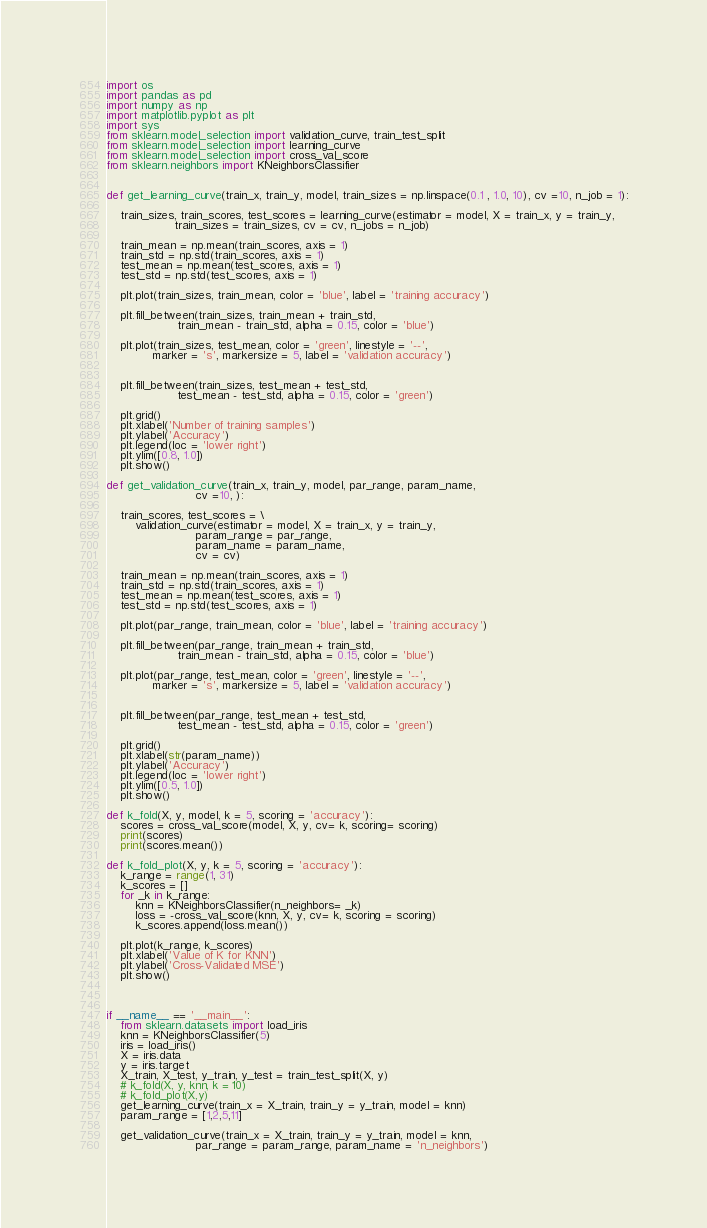Convert code to text. <code><loc_0><loc_0><loc_500><loc_500><_Python_>import os
import pandas as pd
import numpy as np
import matplotlib.pyplot as plt
import sys
from sklearn.model_selection import validation_curve, train_test_split
from sklearn.model_selection import learning_curve
from sklearn.model_selection import cross_val_score 
from sklearn.neighbors import KNeighborsClassifier


def get_learning_curve(train_x, train_y, model, train_sizes = np.linspace(0.1 , 1.0, 10), cv =10, n_job = 1):
    
    train_sizes, train_scores, test_scores = learning_curve(estimator = model, X = train_x, y = train_y,
                   train_sizes = train_sizes, cv = cv, n_jobs = n_job)
    
    train_mean = np.mean(train_scores, axis = 1)
    train_std = np.std(train_scores, axis = 1)
    test_mean = np.mean(test_scores, axis = 1)
    test_std = np.std(test_scores, axis = 1)

    plt.plot(train_sizes, train_mean, color = 'blue', label = 'training accuracy')

    plt.fill_between(train_sizes, train_mean + train_std,
                    train_mean - train_std, alpha = 0.15, color = 'blue')
    
    plt.plot(train_sizes, test_mean, color = 'green', linestyle = '--',
             marker = 's', markersize = 5, label = 'validation accuracy')
    

    plt.fill_between(train_sizes, test_mean + test_std,
                    test_mean - test_std, alpha = 0.15, color = 'green')
    
    plt.grid()
    plt.xlabel('Number of training samples')
    plt.ylabel('Accuracy')
    plt.legend(loc = 'lower right')
    plt.ylim([0.8, 1.0])    
    plt.show()

def get_validation_curve(train_x, train_y, model, par_range, param_name,
                         cv =10, ):
    
    train_scores, test_scores = \
        validation_curve(estimator = model, X = train_x, y = train_y,
                         param_range = par_range,
                         param_name = param_name,
                         cv = cv)
    
    train_mean = np.mean(train_scores, axis = 1)
    train_std = np.std(train_scores, axis = 1)
    test_mean = np.mean(test_scores, axis = 1)
    test_std = np.std(test_scores, axis = 1)

    plt.plot(par_range, train_mean, color = 'blue', label = 'training accuracy')

    plt.fill_between(par_range, train_mean + train_std,
                    train_mean - train_std, alpha = 0.15, color = 'blue')
    
    plt.plot(par_range, test_mean, color = 'green', linestyle = '--',
             marker = 's', markersize = 5, label = 'validation accuracy')
    

    plt.fill_between(par_range, test_mean + test_std,
                    test_mean - test_std, alpha = 0.15, color = 'green')
    
    plt.grid()
    plt.xlabel(str(param_name))
    plt.ylabel('Accuracy')
    plt.legend(loc = 'lower right')
    plt.ylim([0.5, 1.0])    
    plt.show()

def k_fold(X, y, model, k = 5, scoring = 'accuracy'):
    scores = cross_val_score(model, X, y, cv= k, scoring= scoring)
    print(scores)
    print(scores.mean())

def k_fold_plot(X, y, k = 5, scoring = 'accuracy'):
    k_range = range(1, 31)
    k_scores = []
    for _k in k_range:
        knn = KNeighborsClassifier(n_neighbors= _k)
        loss = -cross_val_score(knn, X, y, cv= k, scoring = scoring)
        k_scores.append(loss.mean())

    plt.plot(k_range, k_scores)
    plt.xlabel('Value of K for KNN')
    plt.ylabel('Cross-Validated MSE')
    plt.show()



if __name__ == '__main__':
    from sklearn.datasets import load_iris
    knn = KNeighborsClassifier(5)
    iris = load_iris()
    X = iris.data
    y = iris.target
    X_train, X_test, y_train, y_test = train_test_split(X, y)
    # k_fold(X, y, knn, k = 10)
    # k_fold_plot(X,y)
    get_learning_curve(train_x = X_train, train_y = y_train, model = knn)
    param_range = [1,2,5,11]

    get_validation_curve(train_x = X_train, train_y = y_train, model = knn,
                         par_range = param_range, param_name = 'n_neighbors')


</code> 